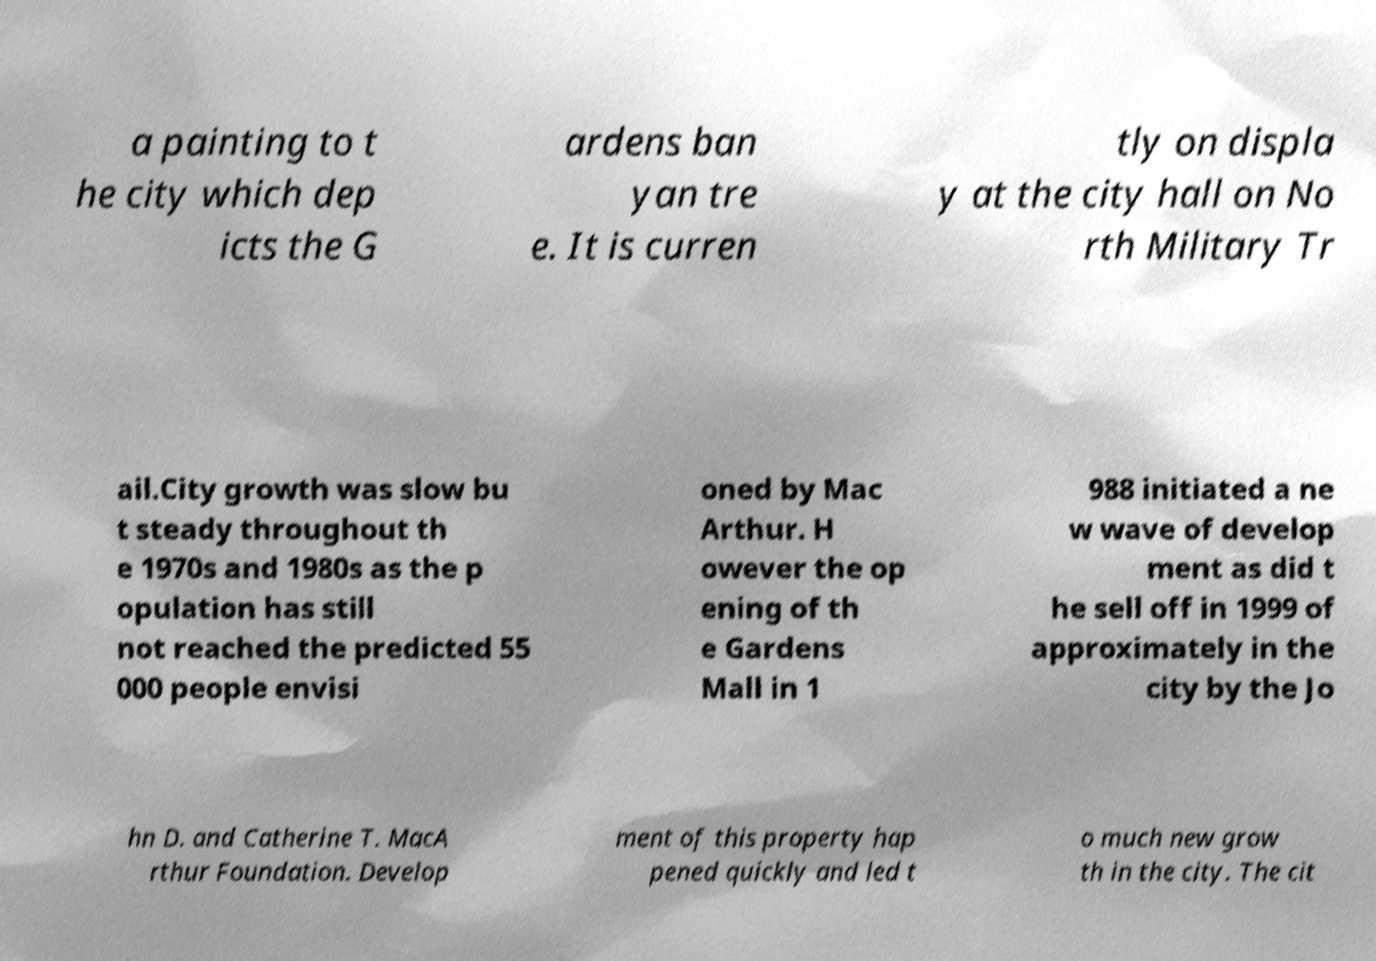What messages or text are displayed in this image? I need them in a readable, typed format. a painting to t he city which dep icts the G ardens ban yan tre e. It is curren tly on displa y at the city hall on No rth Military Tr ail.City growth was slow bu t steady throughout th e 1970s and 1980s as the p opulation has still not reached the predicted 55 000 people envisi oned by Mac Arthur. H owever the op ening of th e Gardens Mall in 1 988 initiated a ne w wave of develop ment as did t he sell off in 1999 of approximately in the city by the Jo hn D. and Catherine T. MacA rthur Foundation. Develop ment of this property hap pened quickly and led t o much new grow th in the city. The cit 